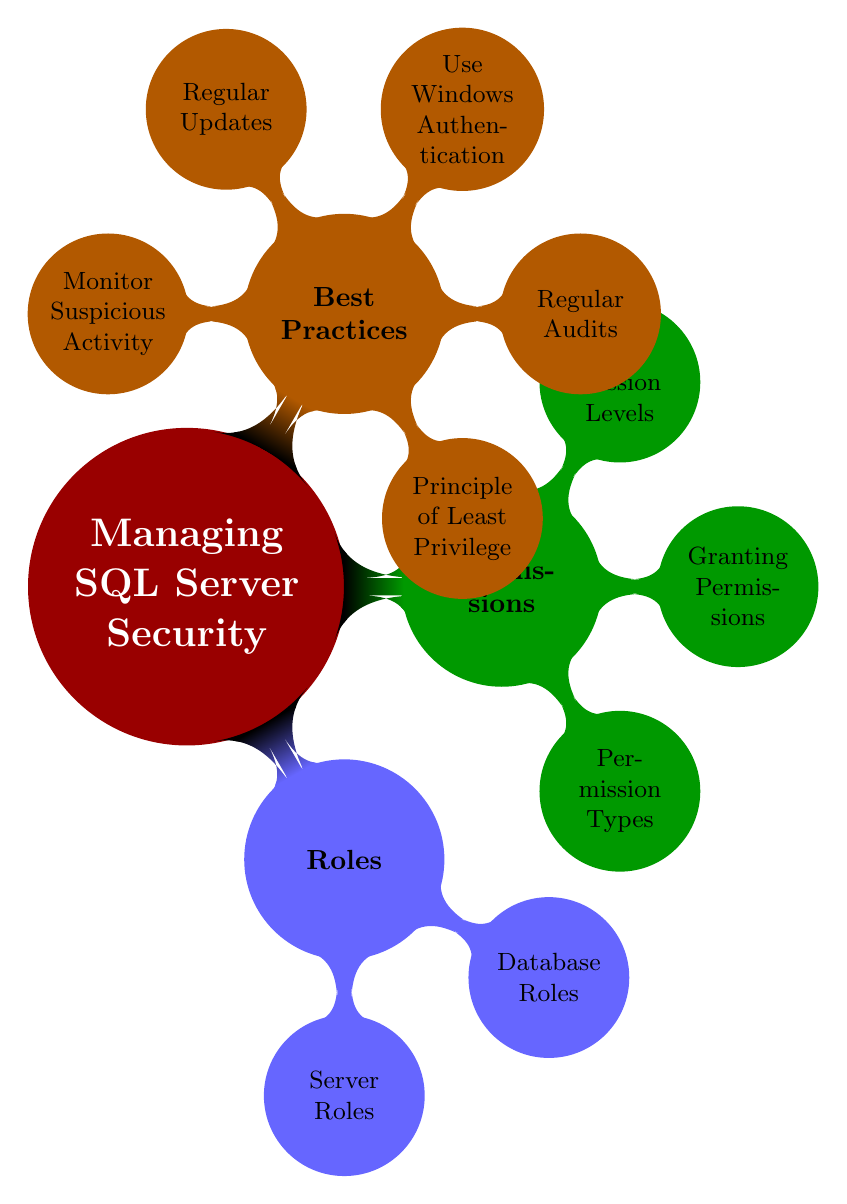What are the two main categories of roles listed in the diagram? The diagram shows "Server Roles" and "Database Roles" as the two main categories of roles under the "Roles" node.
Answer: Server Roles, Database Roles How many fixed database roles are mentioned in the diagram? By counting the entries under "Fixed Database Roles," which are listed as specific roles within the "Database Roles" category, we find eight roles total.
Answer: 8 What is the principle emphasized in the best practices section? The section labeled "Best Practices" specifies the "Principle of Least Privilege" as a fundamental concept, highlighting the need to minimize permissions granted.
Answer: Principle of Least Privilege What permission type is not explicitly listed in the permission types? The "Permission Types" include several actions but do not explicitly mention "GRANT", "DENY", and "REVOKE” as they relate to permissions themselves rather than being types of permissions, indicating that "EXECUTE" is not listed for action types like GRANT or REVOKE.
Answer: EXECUTE Which node has the most child nodes listed? The "Best Practices" node has five child nodes, making it the node with the most subcategories, compared to others with fewer entries.
Answer: Best Practices What permission level indicates the broadest scope of permissions? The "Server-level" permission is listed under "Permission Levels" as the highest scope, providing the most extensive access compared to more specific levels.
Answer: Server-level What are custom roles based on? The diagram states that "Custom Roles" are user-defined roles created based on specific needs, indicating flexibility in permissions configuration.
Answer: Specific needs How many types of permissions are highlighted in the diagram? There are seven different types of permissions listed under "Permission Types," which is a straightforward count from that node.
Answer: 7 